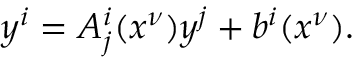Convert formula to latex. <formula><loc_0><loc_0><loc_500><loc_500>y ^ { i } = A _ { j } ^ { i } ( x ^ { \nu } ) y ^ { j } + b ^ { i } ( x ^ { \nu } ) .</formula> 